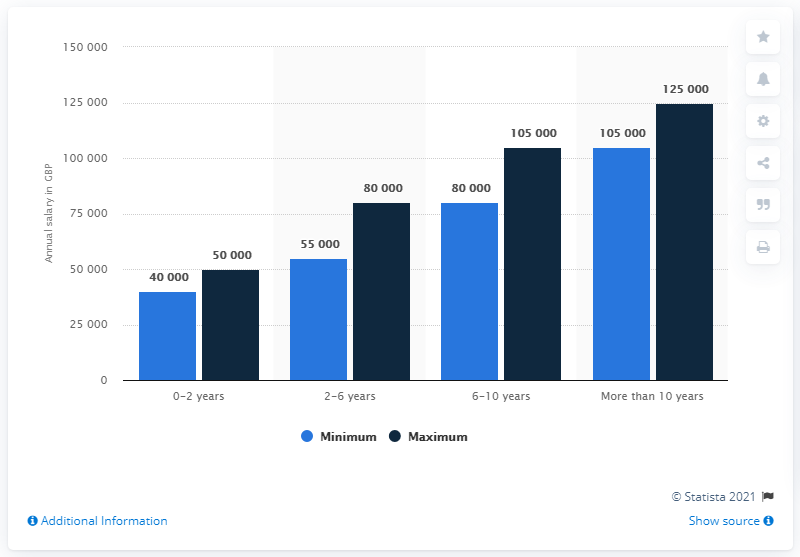Specify some key components in this picture. The blue bar has a low value of 40000. The average value for 6-10 years old is 9,2500. 